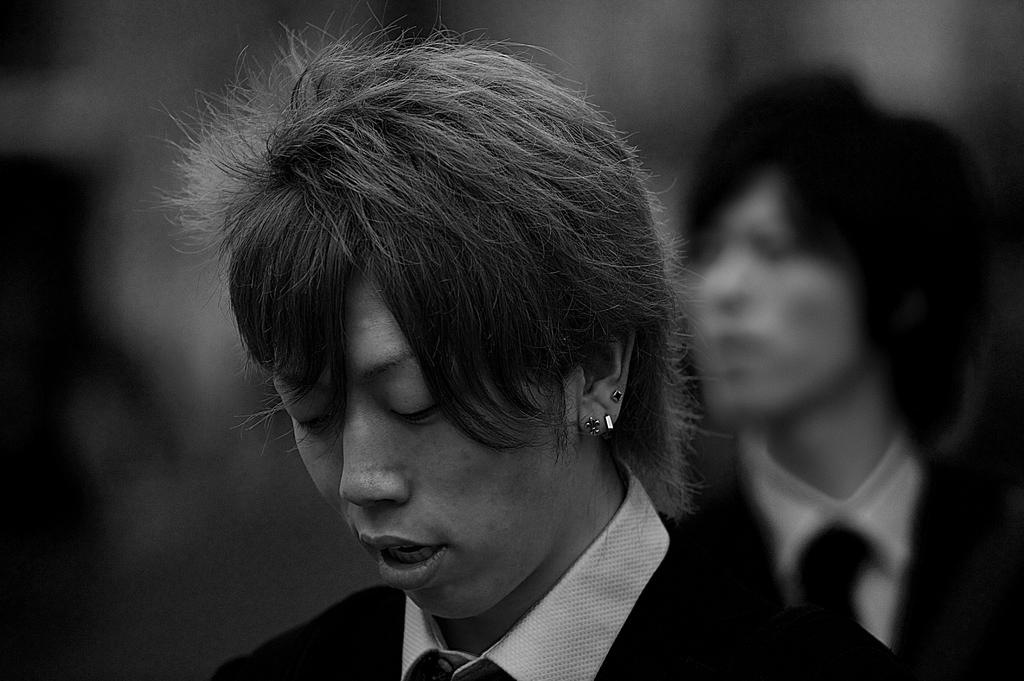How many people are in the image? There are two persons in the image. Can you describe the background of the image? The background of the image is blurred. What type of care is being provided to the person in the image? There is no indication in the image that any care is being provided, as the focus is on the two persons and the blurred background. 